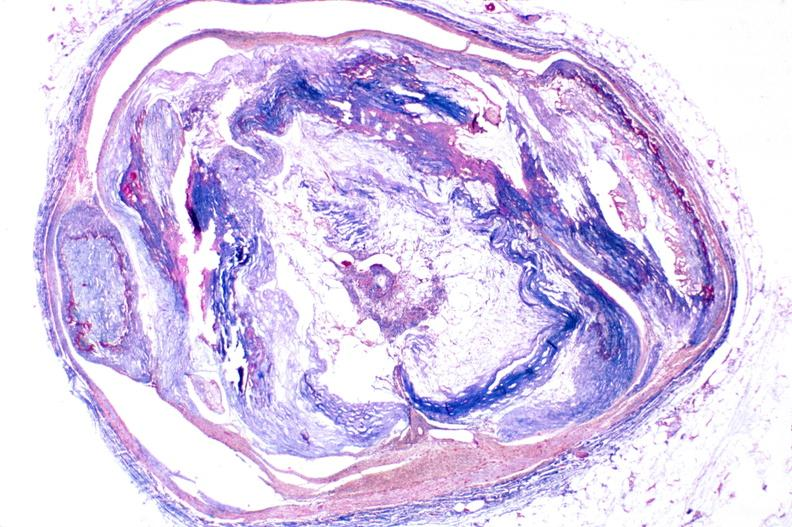s chest and abdomen slide present?
Answer the question using a single word or phrase. No 